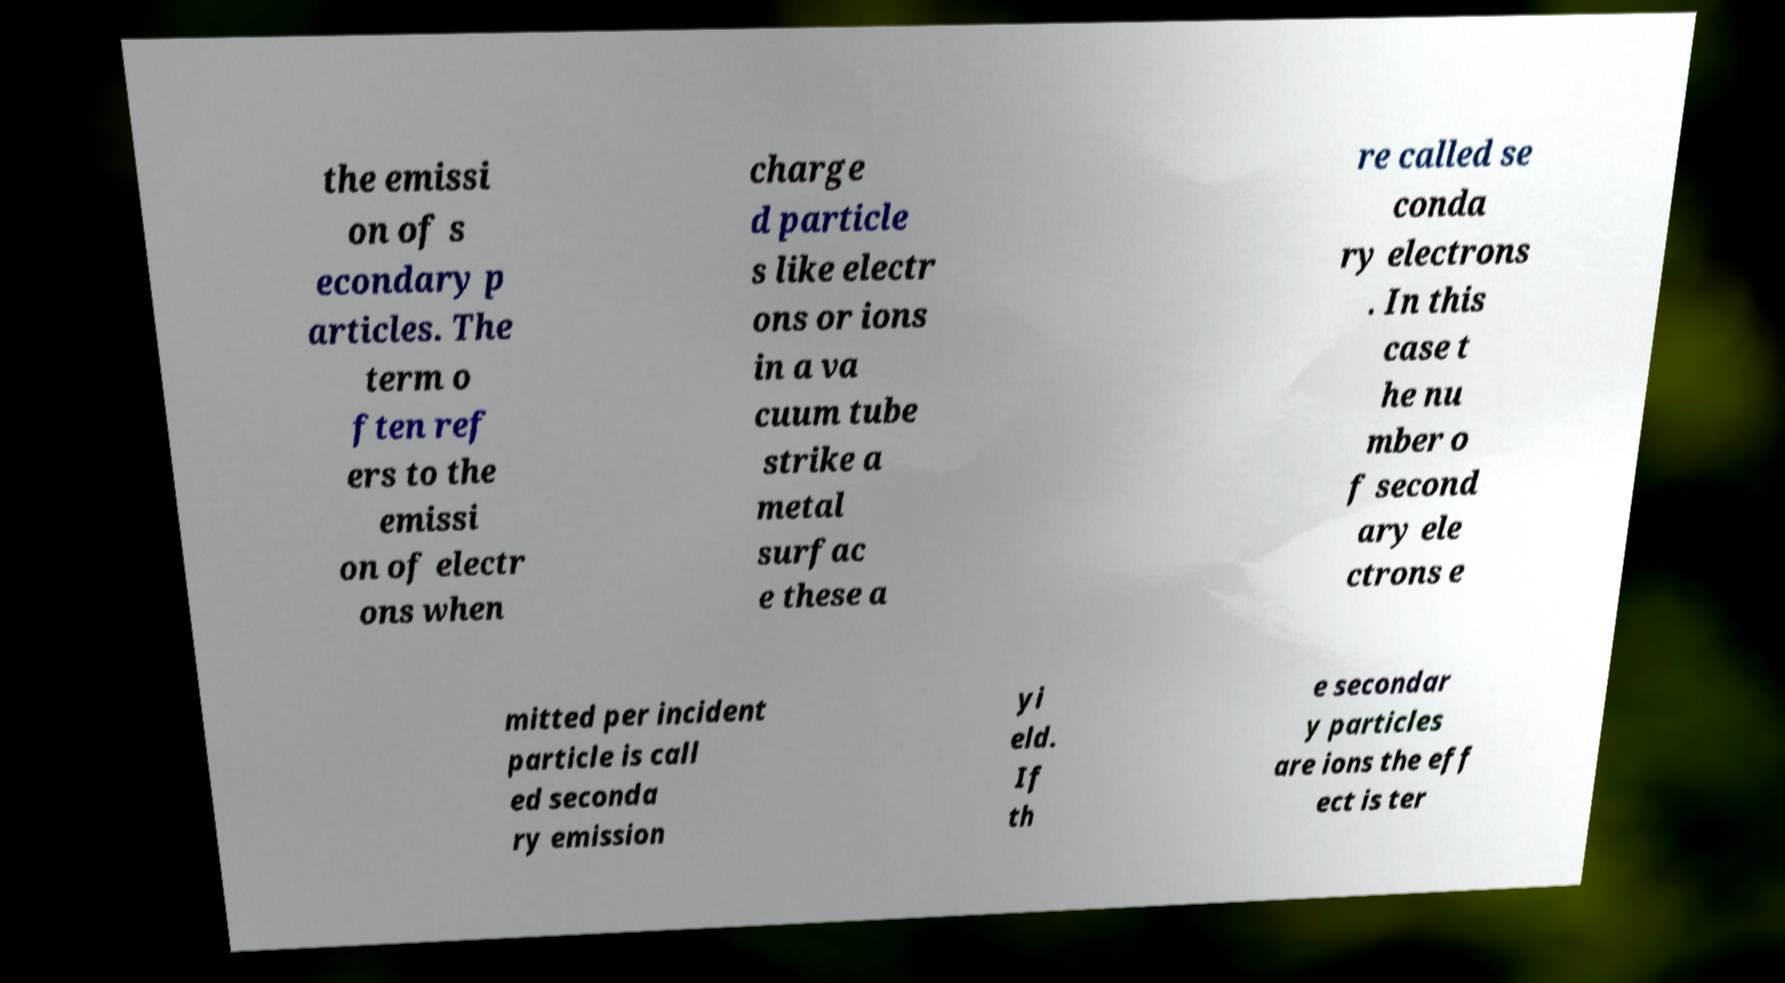I need the written content from this picture converted into text. Can you do that? the emissi on of s econdary p articles. The term o ften ref ers to the emissi on of electr ons when charge d particle s like electr ons or ions in a va cuum tube strike a metal surfac e these a re called se conda ry electrons . In this case t he nu mber o f second ary ele ctrons e mitted per incident particle is call ed seconda ry emission yi eld. If th e secondar y particles are ions the eff ect is ter 